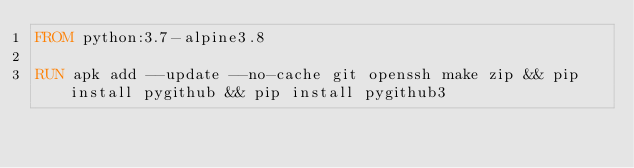<code> <loc_0><loc_0><loc_500><loc_500><_Dockerfile_>FROM python:3.7-alpine3.8

RUN apk add --update --no-cache git openssh make zip && pip install pygithub && pip install pygithub3
</code> 